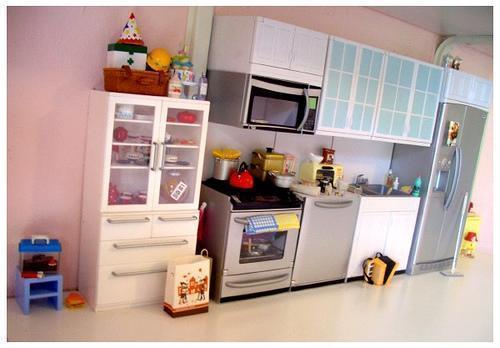What type of people obviously live here?
Make your selection from the four choices given to correctly answer the question.
Options: Children, middle aged, elderly, infirm. Children. 